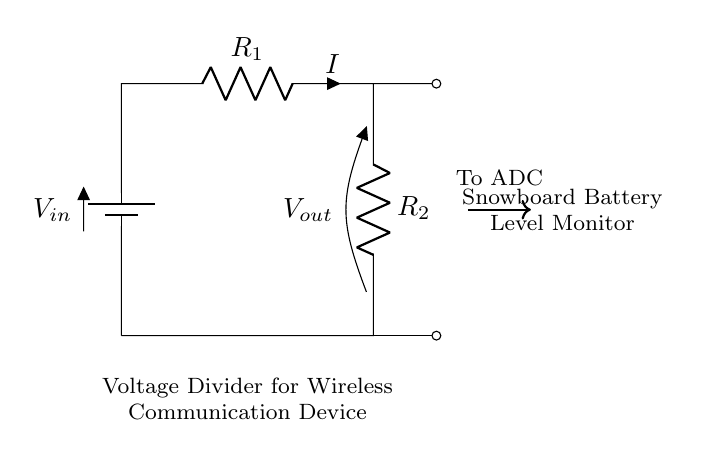What is the input voltage of the circuit? The input voltage is represented by \( V_{in} \) in the circuit diagram, which is generally defined by the battery connection.
Answer: \( V_{in} \) What do \( R_1 \) and \( R_2 \) represent? \( R_1 \) and \( R_2 \) are resistors in the voltage divider circuit, where \( R_1 \) is connected above \( R_2 \).
Answer: Resistors What is the purpose of this circuit? The purpose of the circuit is to monitor the battery levels of a snowboard by providing a scaled down voltage to an Analog-to-Digital Converter (ADC).
Answer: Battery level monitor How is \( V_{out} \) related to \( V_{in} \)? \( V_{out} \) is the output voltage taken across \( R_2 \) and is a fraction of \( V_{in} \), determined by the values of \( R_1 \) and \( R_2 \).
Answer: Scaled voltage If \( R_1 \) is 10 ohms and \( R_2 \) is 20 ohms, what is the voltage division ratio? The voltage division ratio can be calculated as \( V_{out}/V_{in} = R_2 / (R_1 + R_2) \), which is \( 20/(10 + 20) = 0.67 \).
Answer: 0.67 What is the output voltage when the input voltage is 12 volts? To find \( V_{out} \), we apply the voltage division formula: \( V_{out} = V_{in} \cdot (R_2 / (R_1 + R_2)) = 12 \cdot (20/(10 + 20)) = 8 \) volts.
Answer: 8 volts 